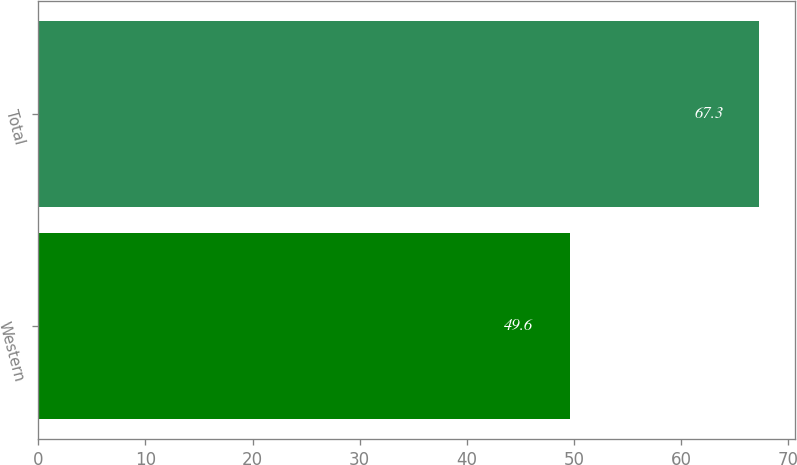Convert chart to OTSL. <chart><loc_0><loc_0><loc_500><loc_500><bar_chart><fcel>Western<fcel>Total<nl><fcel>49.6<fcel>67.3<nl></chart> 